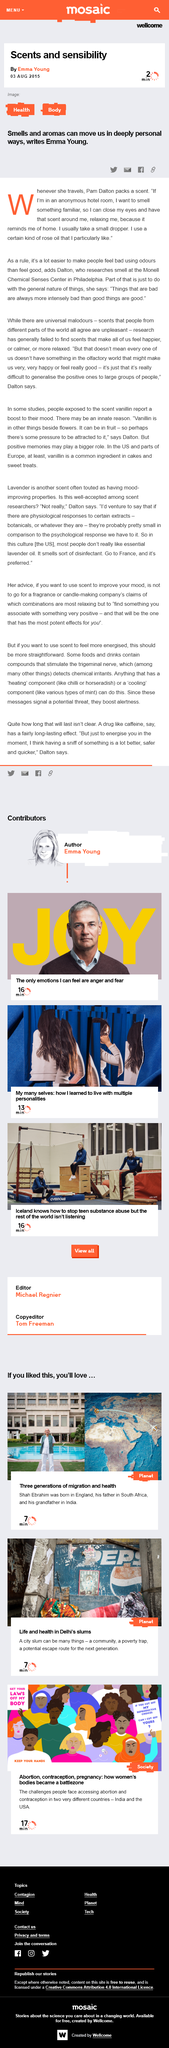Outline some significant characteristics in this image. Pam Dalton has a preference for a specific type of rose oil. Pam Dalton conducts research on smell at the Monell Chemical Senses Center located in Philadelphia. The article 'scents and sensibility' was written by Emma Young. 